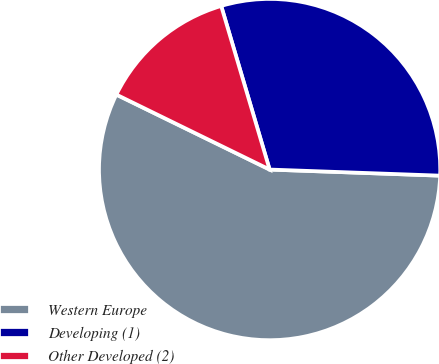Convert chart to OTSL. <chart><loc_0><loc_0><loc_500><loc_500><pie_chart><fcel>Western Europe<fcel>Developing (1)<fcel>Other Developed (2)<nl><fcel>56.67%<fcel>30.15%<fcel>13.18%<nl></chart> 